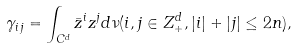Convert formula to latex. <formula><loc_0><loc_0><loc_500><loc_500>\gamma _ { i j } = \int _ { C ^ { d } } \bar { z } ^ { i } z ^ { j } d \nu ( i , j \in Z _ { + } ^ { d } , | i | + | j | \leq 2 n ) ,</formula> 